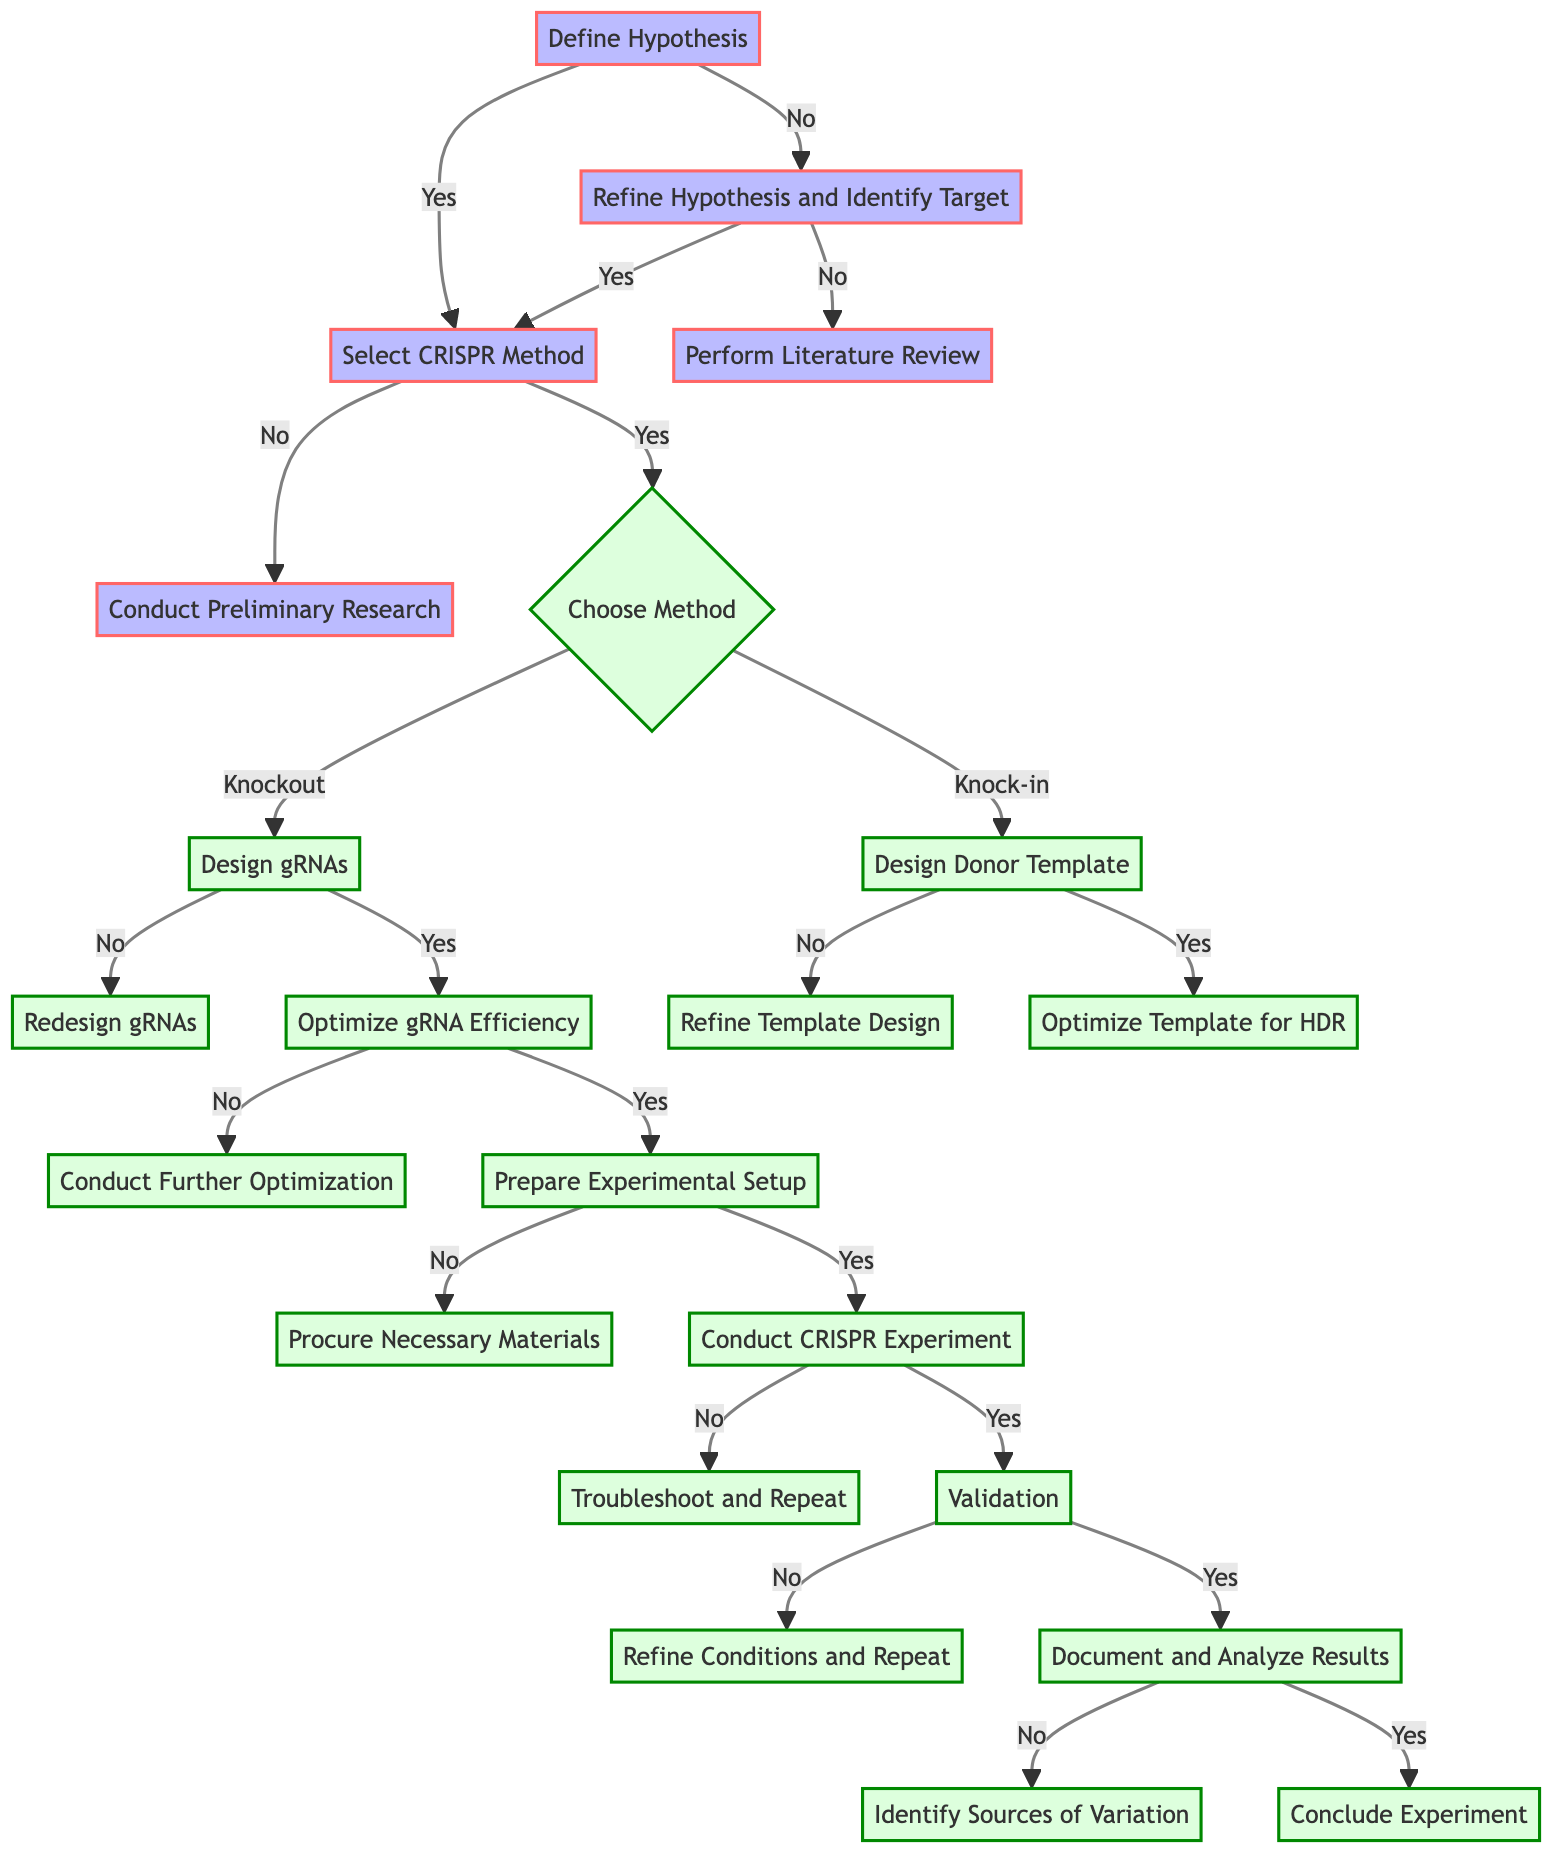What is the first step in the decision tree? The first step in the decision tree is indicated by the starting node labeled "Define Hypothesis," which serves as the initial action to take in the experimental design process.
Answer: Define Hypothesis How many main stages are in the decision tree? By counting the unique stages presented, there are a total of 9 main stages represented in the flow, leading from defining the hypothesis to concluding the experiment.
Answer: 9 What do you do if the target gene and location are not clearly identified? The diagram indicates that if the target gene and location are not identified, the next step is to "Refine Hypothesis and Identify Target." This is a direct flow from the decision node.
Answer: Refine Hypothesis and Identify Target What happens after validating the gene edit is confirmed and functional? Once the gene edit is confirmed to be functional, the next action is to "Document and Analyze Results," which suggests a focus on data management and evaluation after successful experiments.
Answer: Document and Analyze Results What is the outcome if the gRNAs do not meet the criteria for specificity? The diagram specifies that if the gRNAs do not ensure specificity and minimize off-target effects, the subsequent step will be to "Redesign gRNAs using Algorithms or CRISPR Design Tools," indicating corrective action is required.
Answer: Redesign gRNAs using Algorithms or CRISPR Design Tools If the CRISPR experiment yields no successful DNA edits, what action should be taken? The decision tree indicates that if the DNA is not successfully edited in the CRISPR experiment, the next step is to "Troubleshoot and Repeat Experiment," which emphasizes the need for troubleshooting protocol.
Answer: Troubleshoot and Repeat Experiment What do you choose between after selecting the CRISPR method? After selecting the CRISPR method, the diagram presents a bifurcation labeled "Choose between Knockout or Knock-in," representing the next decision point regarding the experimental approach.
Answer: Choose between Knockout or Knock-in What must be ensured if using a donor template for gene editing? The diagram highlights that if a donor template is used, it is crucial to confirm that the donor template is "correctly mapped to target site," as indicated in that decision node.
Answer: Correctly mapped to target site What kind of testing is necessary before preparing the experimental setup? The flow of the diagram indicates that it is necessary to ensure that the gRNAs are "tested in vitro or in silico successfully" before moving on to prepare the experimental setup.
Answer: Tested in vitro or in silico successfully 